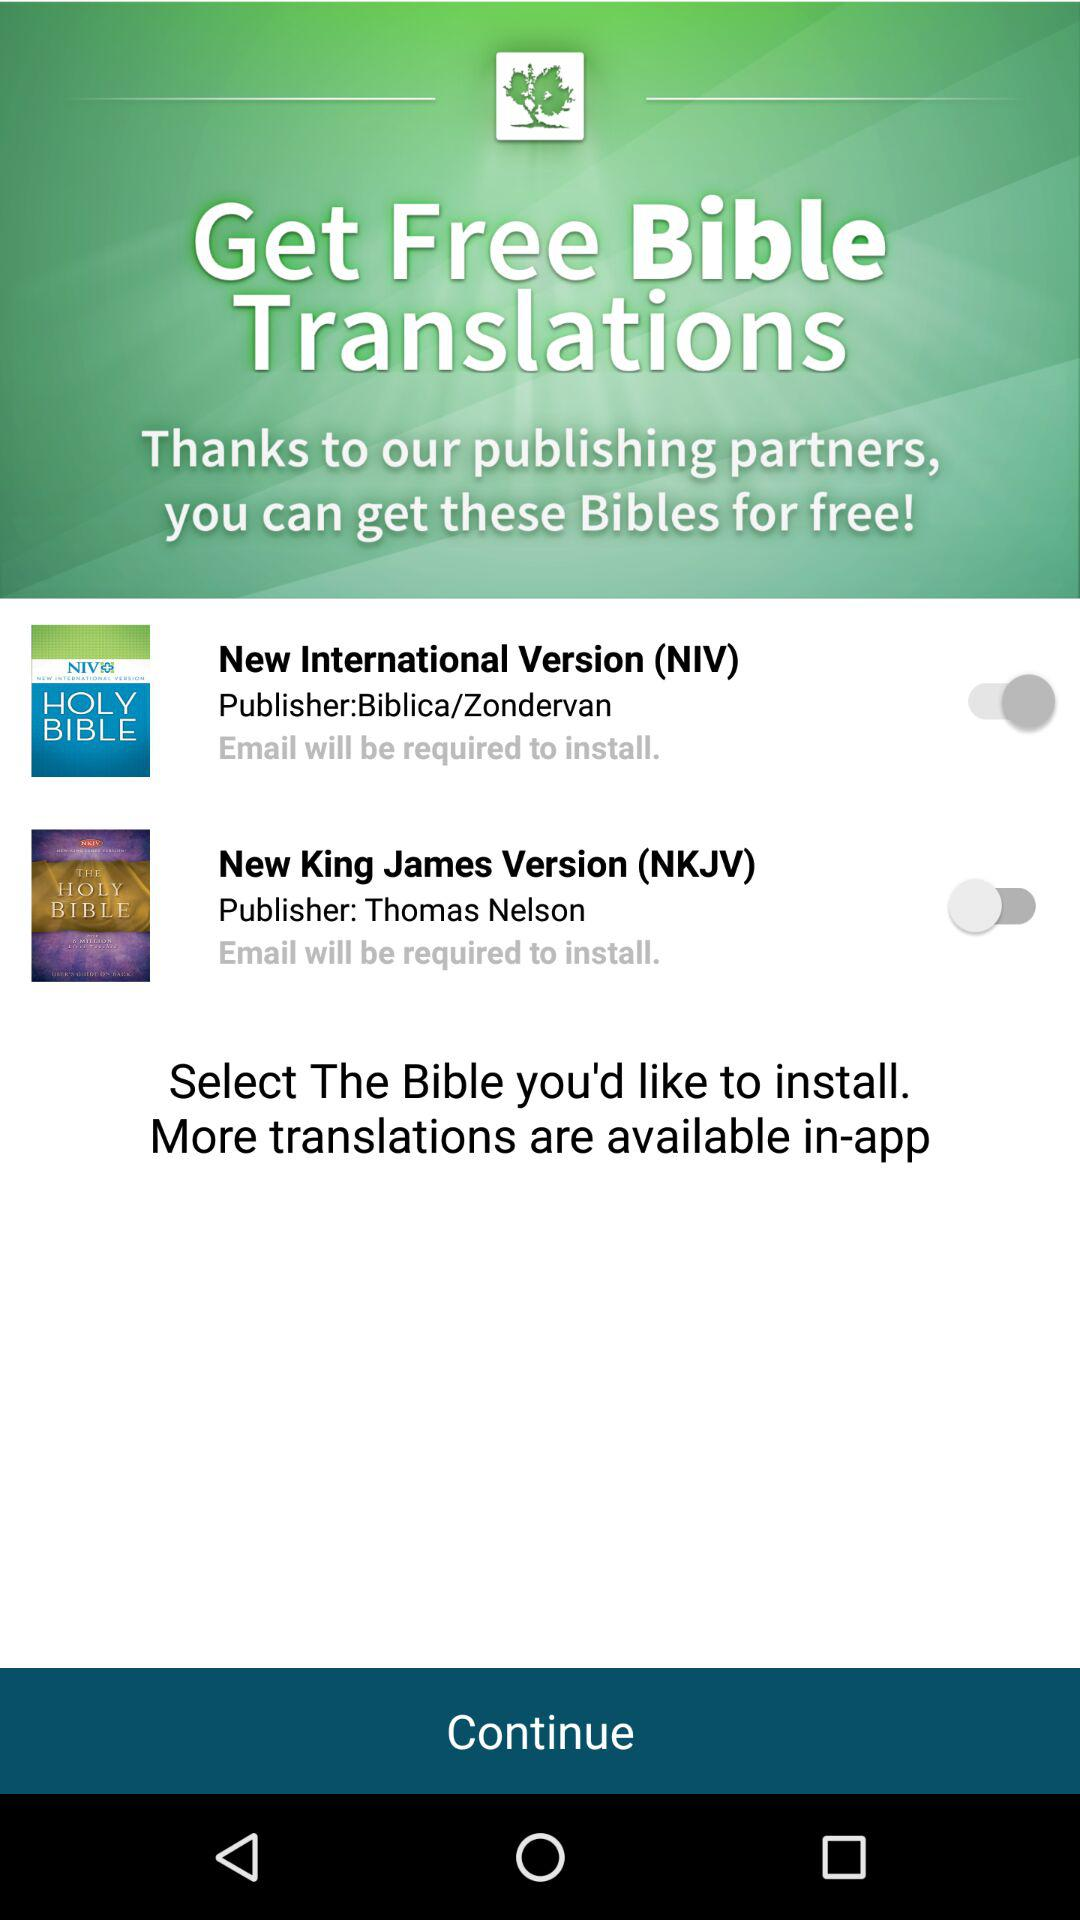What is the application name? The application names are "New International Version (NIV)" and "New King James Version (NKJV)". 